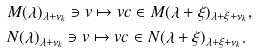Convert formula to latex. <formula><loc_0><loc_0><loc_500><loc_500>& M ( \lambda ) _ { \lambda + \nu _ { k } } \ni v \mapsto v c \in M ( \lambda + \xi ) _ { \lambda + \xi + \nu _ { k } } , \\ & N ( \lambda ) _ { \lambda + \nu _ { k } } \ni v \mapsto v c \in N ( \lambda + \xi ) _ { \lambda + \xi + \nu _ { k } } .</formula> 